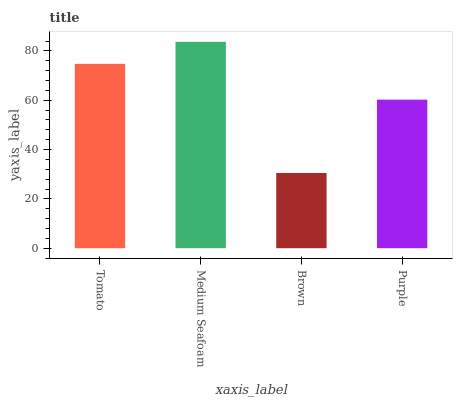Is Brown the minimum?
Answer yes or no. Yes. Is Medium Seafoam the maximum?
Answer yes or no. Yes. Is Medium Seafoam the minimum?
Answer yes or no. No. Is Brown the maximum?
Answer yes or no. No. Is Medium Seafoam greater than Brown?
Answer yes or no. Yes. Is Brown less than Medium Seafoam?
Answer yes or no. Yes. Is Brown greater than Medium Seafoam?
Answer yes or no. No. Is Medium Seafoam less than Brown?
Answer yes or no. No. Is Tomato the high median?
Answer yes or no. Yes. Is Purple the low median?
Answer yes or no. Yes. Is Brown the high median?
Answer yes or no. No. Is Brown the low median?
Answer yes or no. No. 